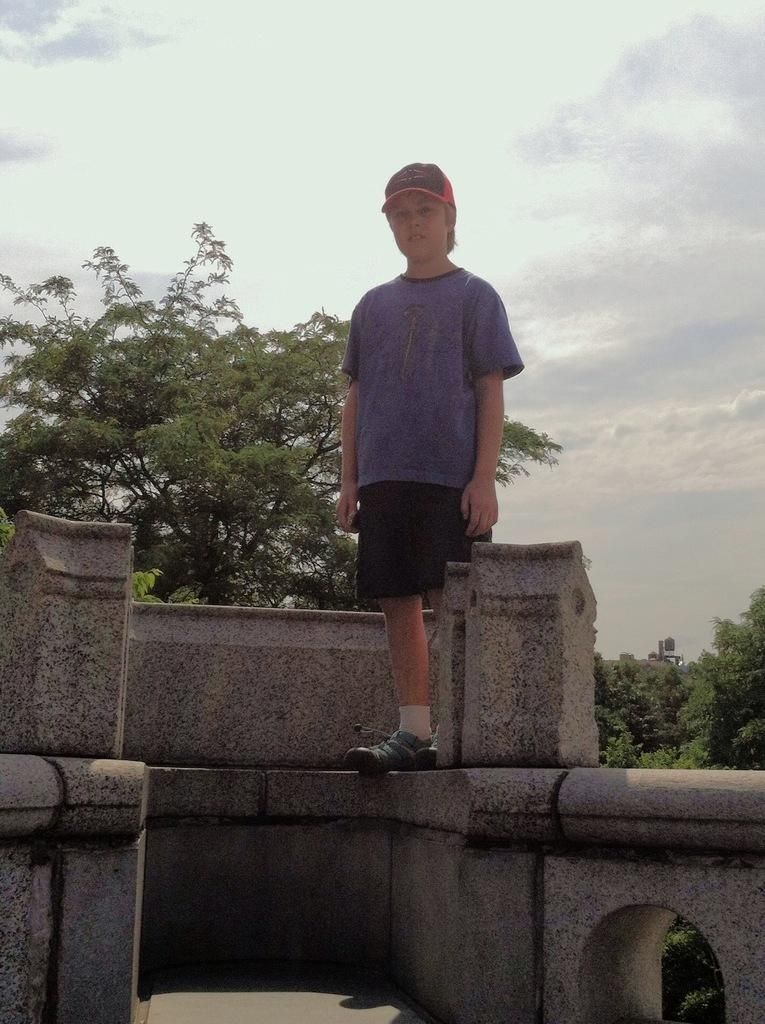What is the person in the image doing? The person is standing on a wall and looking at a picture. What can be seen in the background of the image? There are many trees in the background of the image. What is visible at the top of the image? The sky is visible at the top of the image. What is the condition of the sky in the image? Clouds are present in the sky. What type of dinner is being served in the image? There is no dinner present in the image; it features a person standing on a wall and looking at a picture. What type of dress is the person wearing in the image? The provided facts do not mention the person's clothing, so we cannot determine the type of dress they are wearing. 